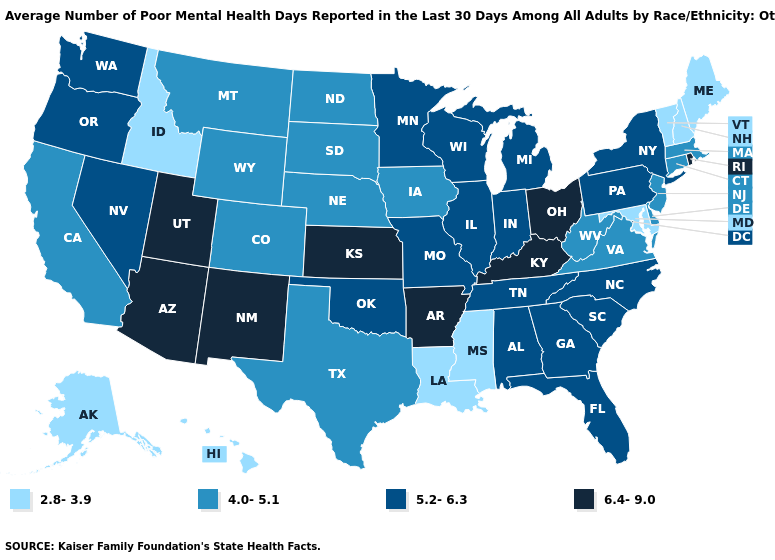Which states hav the highest value in the West?
Keep it brief. Arizona, New Mexico, Utah. What is the lowest value in the USA?
Give a very brief answer. 2.8-3.9. Does New Mexico have the highest value in the USA?
Answer briefly. Yes. Which states have the lowest value in the USA?
Give a very brief answer. Alaska, Hawaii, Idaho, Louisiana, Maine, Maryland, Mississippi, New Hampshire, Vermont. Does New Mexico have the highest value in the USA?
Be succinct. Yes. What is the highest value in the Northeast ?
Concise answer only. 6.4-9.0. Does Nevada have a higher value than Maine?
Keep it brief. Yes. Name the states that have a value in the range 6.4-9.0?
Concise answer only. Arizona, Arkansas, Kansas, Kentucky, New Mexico, Ohio, Rhode Island, Utah. How many symbols are there in the legend?
Keep it brief. 4. Which states have the highest value in the USA?
Be succinct. Arizona, Arkansas, Kansas, Kentucky, New Mexico, Ohio, Rhode Island, Utah. Name the states that have a value in the range 4.0-5.1?
Answer briefly. California, Colorado, Connecticut, Delaware, Iowa, Massachusetts, Montana, Nebraska, New Jersey, North Dakota, South Dakota, Texas, Virginia, West Virginia, Wyoming. Name the states that have a value in the range 6.4-9.0?
Short answer required. Arizona, Arkansas, Kansas, Kentucky, New Mexico, Ohio, Rhode Island, Utah. Among the states that border Washington , does Oregon have the highest value?
Answer briefly. Yes. Name the states that have a value in the range 6.4-9.0?
Be succinct. Arizona, Arkansas, Kansas, Kentucky, New Mexico, Ohio, Rhode Island, Utah. What is the value of Connecticut?
Quick response, please. 4.0-5.1. 